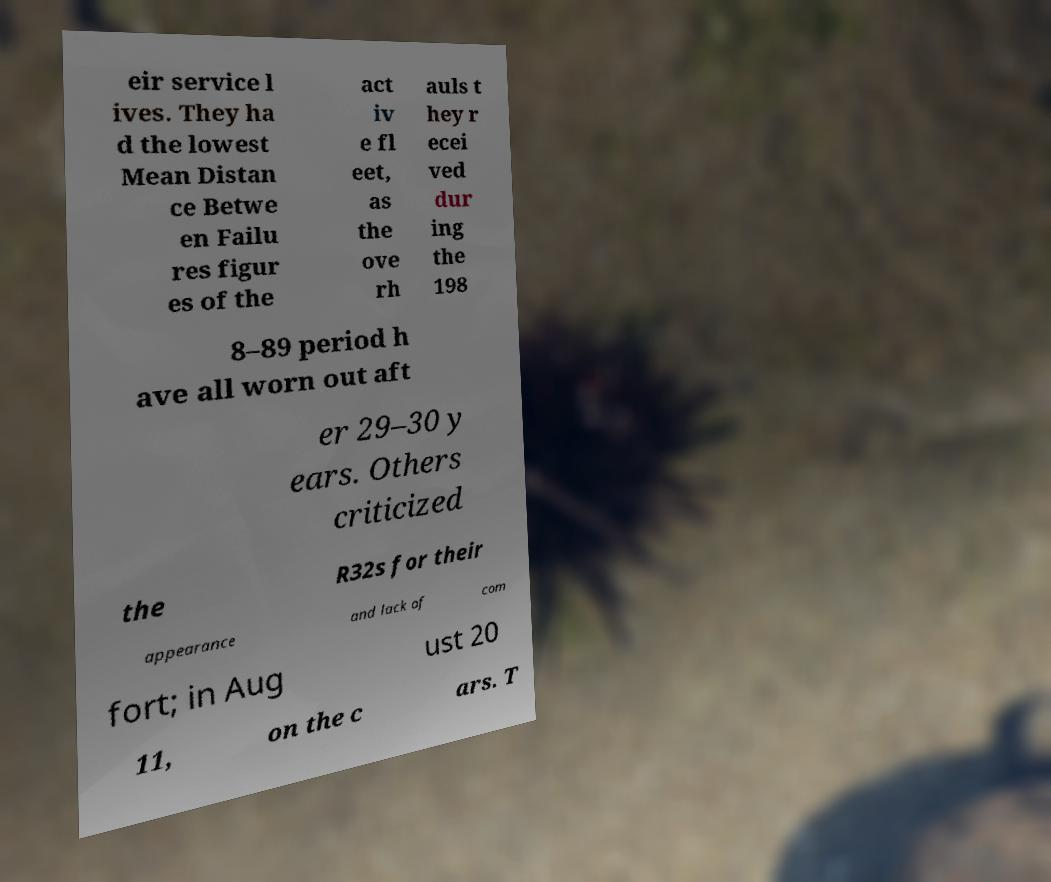What messages or text are displayed in this image? I need them in a readable, typed format. eir service l ives. They ha d the lowest Mean Distan ce Betwe en Failu res figur es of the act iv e fl eet, as the ove rh auls t hey r ecei ved dur ing the 198 8–89 period h ave all worn out aft er 29–30 y ears. Others criticized the R32s for their appearance and lack of com fort; in Aug ust 20 11, on the c ars. T 